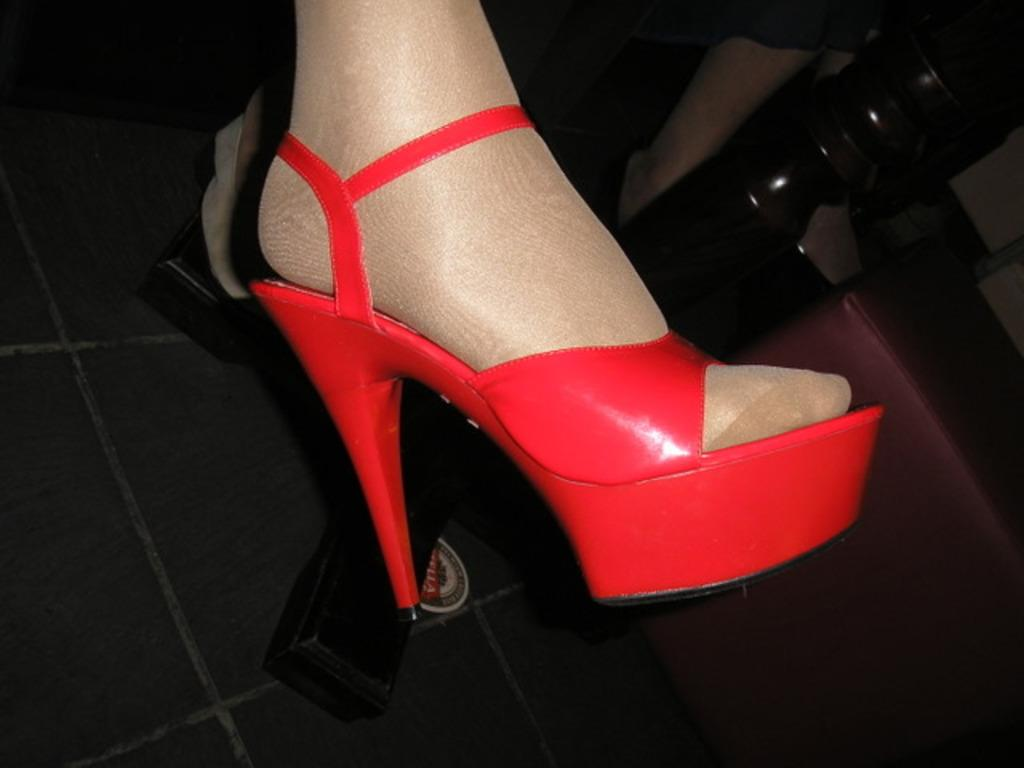What part of a person's body is visible in the image? There is a person's leg in the image. What type of footwear is the person wearing? The person is wearing red color footwear. What object can be seen on the floor in the image? There is a pole on the floor in the image. How many sisters does the person with the red footwear have in the image? There is no information about the person's sisters in the image. 